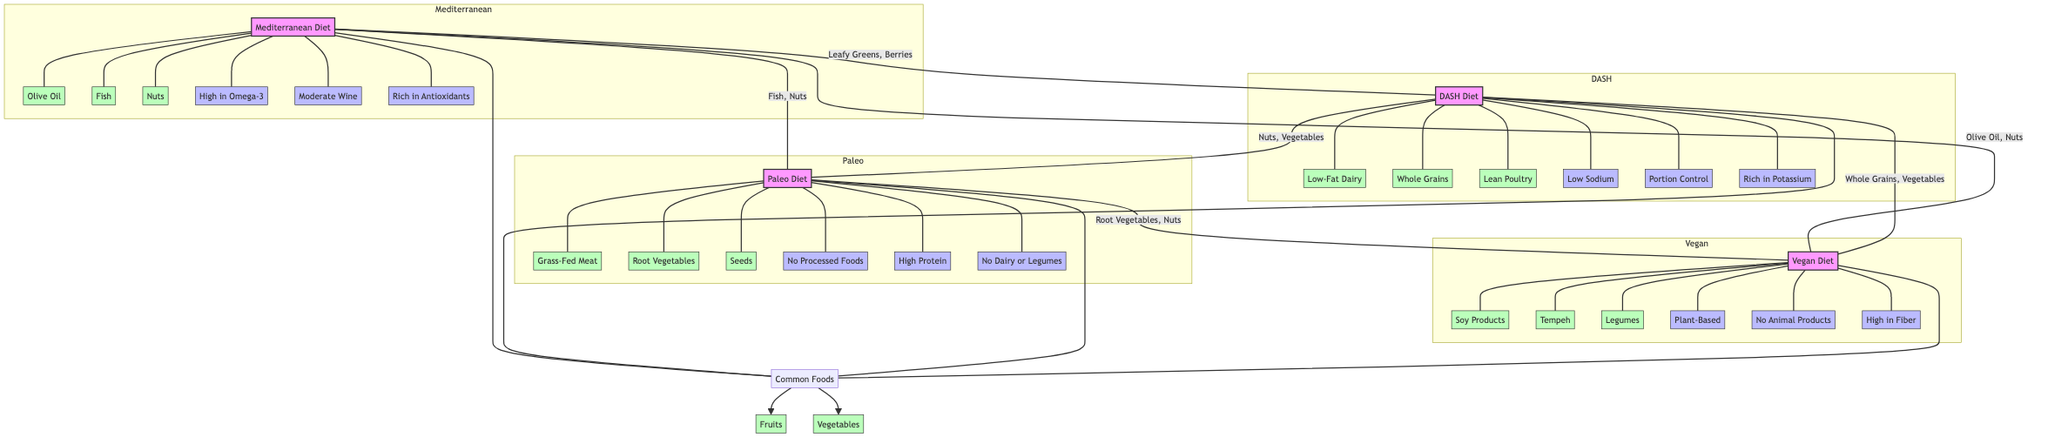What are the unique foods in the Mediterranean Diet? The Mediterranean Diet includes unique foods such as Olive Oil, Fish, and Nuts. These foods are listed specifically under the Mediterranean Diet node and are not connected to any others in the diagram.
Answer: Olive Oil, Fish, Nuts How many principles does the Vegan Diet encompass? The Vegan Diet has three principles: Plant-Based, No Animal Products, and High in Fiber. By counting the distinct nodes connected to the Vegan Diet node, we find that there are exactly three principles represented.
Answer: 3 Which diet shares Root Vegetables with Paleo? Root Vegetables are uniquely linked between the Paleo Diet and the Vegan Diet within the Venn diagram, indicating that both plans feature this specific food. It is visible in the area of overlap between these two diets.
Answer: Vegan Diet What common foods are listed across all diets? The common foods listed across all diets are Fruits and Vegetables. These foods are categorized under the Common label and are connected to all four diet styles, indicating they are shared among all.
Answer: Fruits, Vegetables Which diet contains the most unique food items? The Paleo Diet contains three unique food items: Grass-Fed Meat, Root Vegetables, and Seeds. As we analyze the unique food items in each diet, we find that the Paleo Diet has the highest count with three unique foods listed.
Answer: Paleo Diet How many total diet styles are represented in the diagram? The diagram illustrates four distinct diet styles: Mediterranean, DASH, Paleo, and Vegan. By identifying each of the subgraph labels in the diagram, we can verify that there are indeed four diet styles present.
Answer: 4 Which two diets share a unique food item with the concept of Nuts? Both the Mediterranean Diet and the DASH Diet share the unique food item Nuts. This shared food is indicated by the overlap between the Mediterranean and DASH Diet nodes in the diagram, showing that both diets include Nuts.
Answer: Mediterranean Diet, DASH Diet Who emphasizes 'No Processed Foods' as a principle? The principle of No Processed Foods is emphasized in the Paleo Diet. This principle is explicitly linked only to the Paleo Diet node in the diagram, making it clear that it is characteristic of this particular diet.
Answer: Paleo Diet 